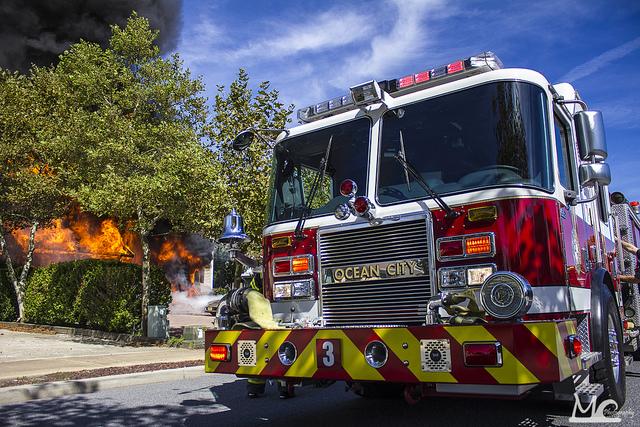How many people are in this truck?
Keep it brief. 0. What is written in the corner of the picture?
Give a very brief answer. Mc. To what state does this fire truck belong?
Write a very short answer. California. What are the number on the front of the fire truck?
Answer briefly. 3. 